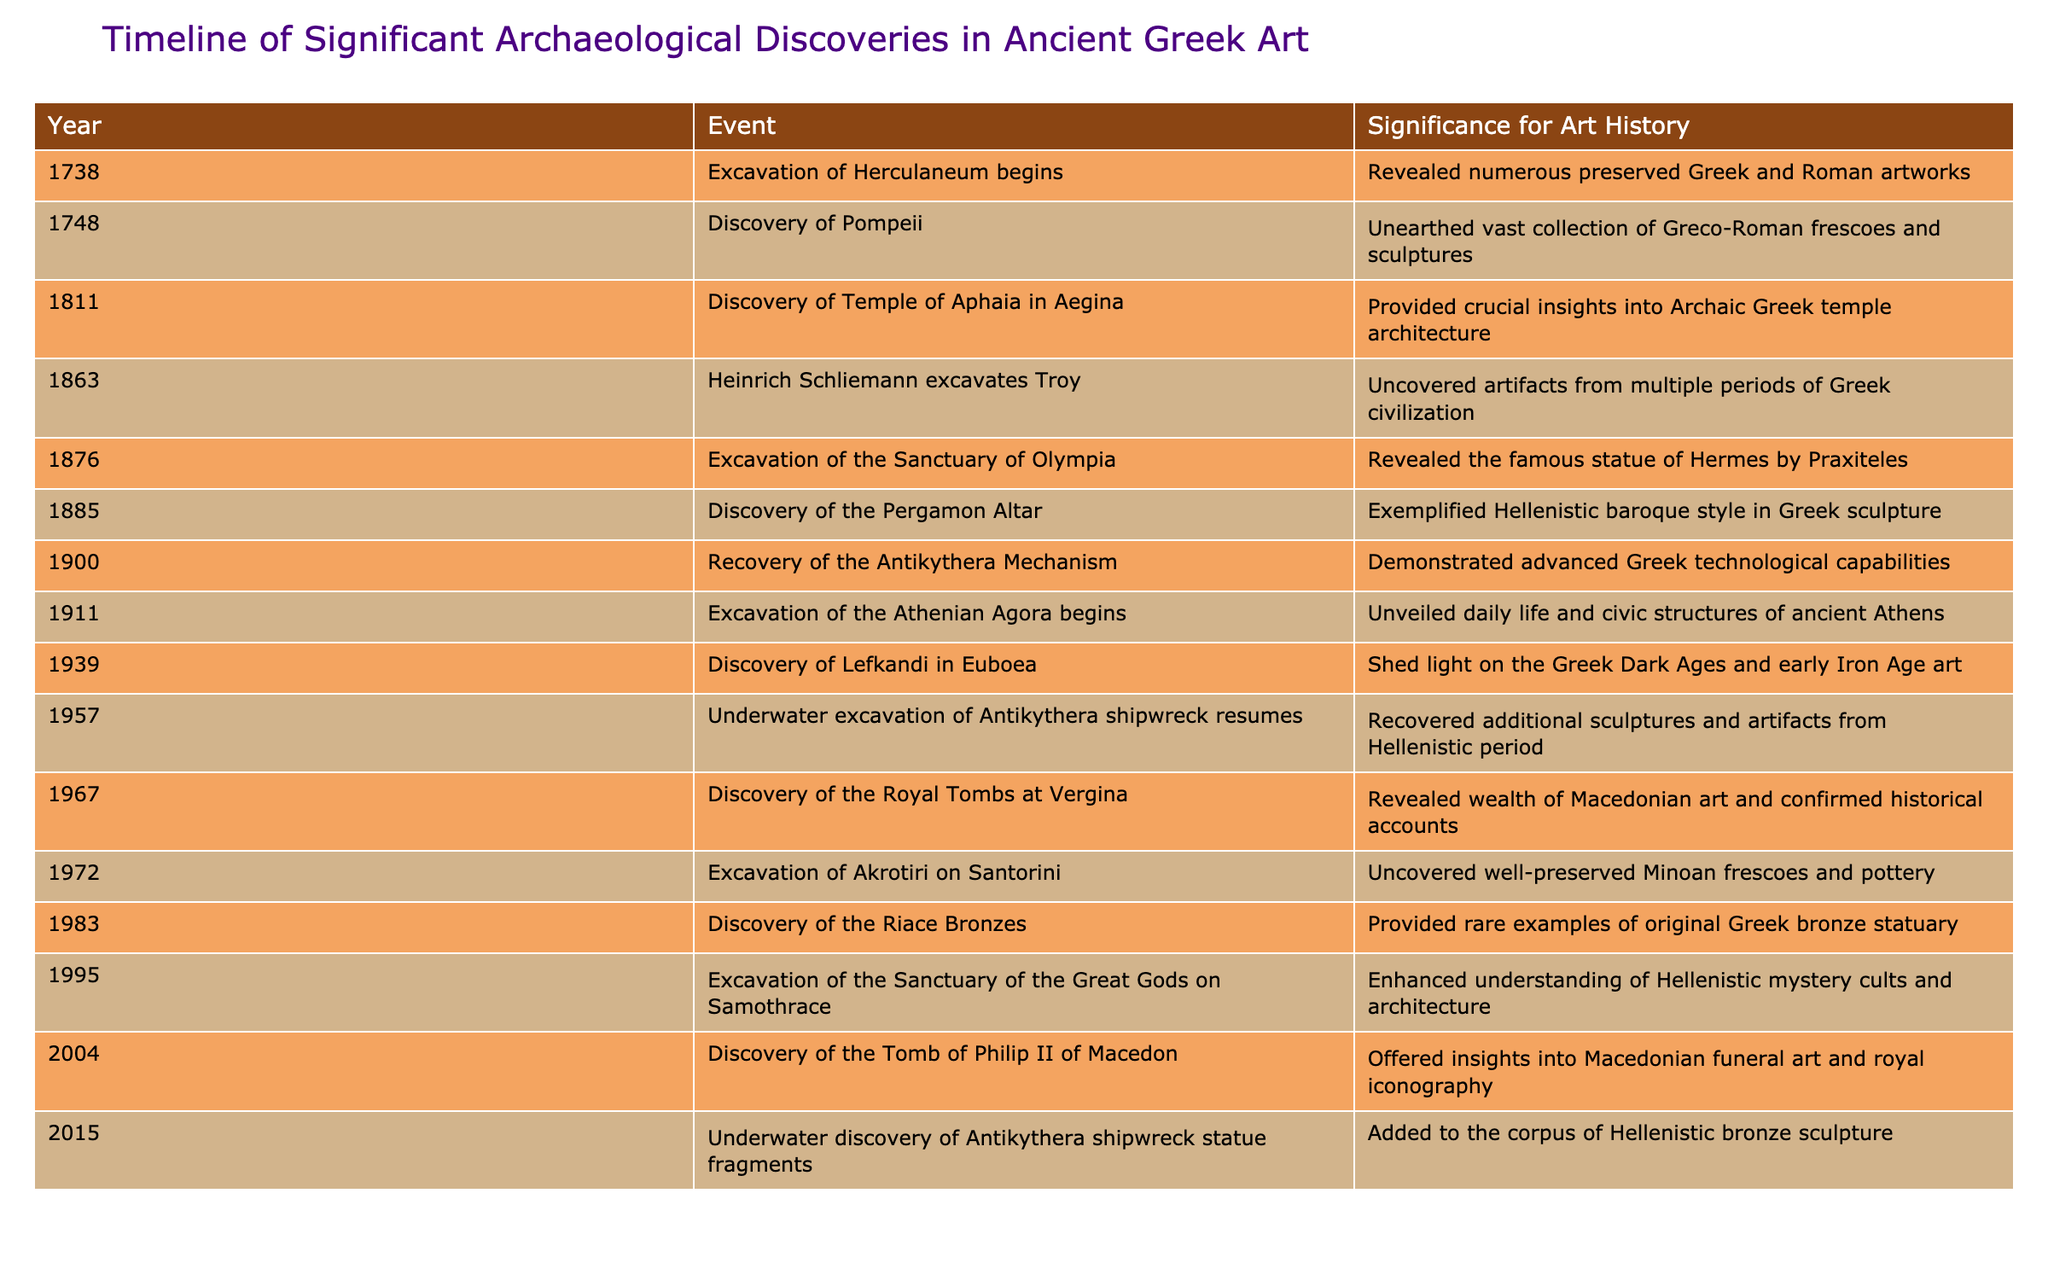What year did the excavation of Herculaneum begin? The table lists the year of the excavation of Herculaneum, which is found under the "Year" column corresponding to the event "Excavation of Herculaneum begins."
Answer: 1738 Which archaeological discovery revealed the famous statue of Hermes by Praxiteles? The table shows the event "Excavation of the Sanctuary of Olympia" which aligns with the discovery of the famous statue of Hermes by Praxiteles in the "Event" column.
Answer: Excavation of the Sanctuary of Olympia How many years passed between the discovery of the Riace Bronzes and the excavation of Akrotiri? The year of the discovery of the Riace Bronzes is 1983, and the excavation of Akrotiri occurred in 1972. The difference is calculated as 1983 - 1972 = 11 years.
Answer: 11 years True or false: The underwater excavations of the Antikythera shipwreck occurred before the discovery of the Royal Tombs at Vergina. By referring to the table, the underwater excavation of Antikythera shipwreck resumed in 1957, while the discovery of the Royal Tombs at Vergina occurred in 1967, confirming it happened first.
Answer: True Which discovery is related to advancing our understanding of Hellenistic mystery cults and architecture? The relevant event listed in the table is "Excavation of the Sanctuary of the Great Gods on Samothrace," which directly addresses the question of insights into Hellenistic mystery cults and architecture.
Answer: Excavation of the Sanctuary of the Great Gods on Samothrace What is the significance of the recovery of the Antikythera Mechanism in terms of technological capabilities? The table states that the recovery of the Antikythera Mechanism demonstrated advanced Greek technological capabilities, indicating its importance as a technological artifact.
Answer: Advanced Greek technological capabilities Which event occurred first: the recovery of the Antikythera Mechanism or the excavation of the Athenian Agora? The year of the recovery of the Antikythera Mechanism is 1900, while the excavation of the Athenian Agora began in 1911. Thus, the recovery of the mechanism occurred first.
Answer: Recovery of the Antikythera Mechanism How many significant archaeological discoveries related to ancient Greek art occurred in the 19th century? Upon reviewing the table, the significant discoveries made during the 19th century are: Temple of Aphaia in Aegina (1811), excavations at Troy (1863), the Sanctuary of Olympia (1876), and the Pergamon Altar (1885), totaling four discoveries.
Answer: 4 discoveries 